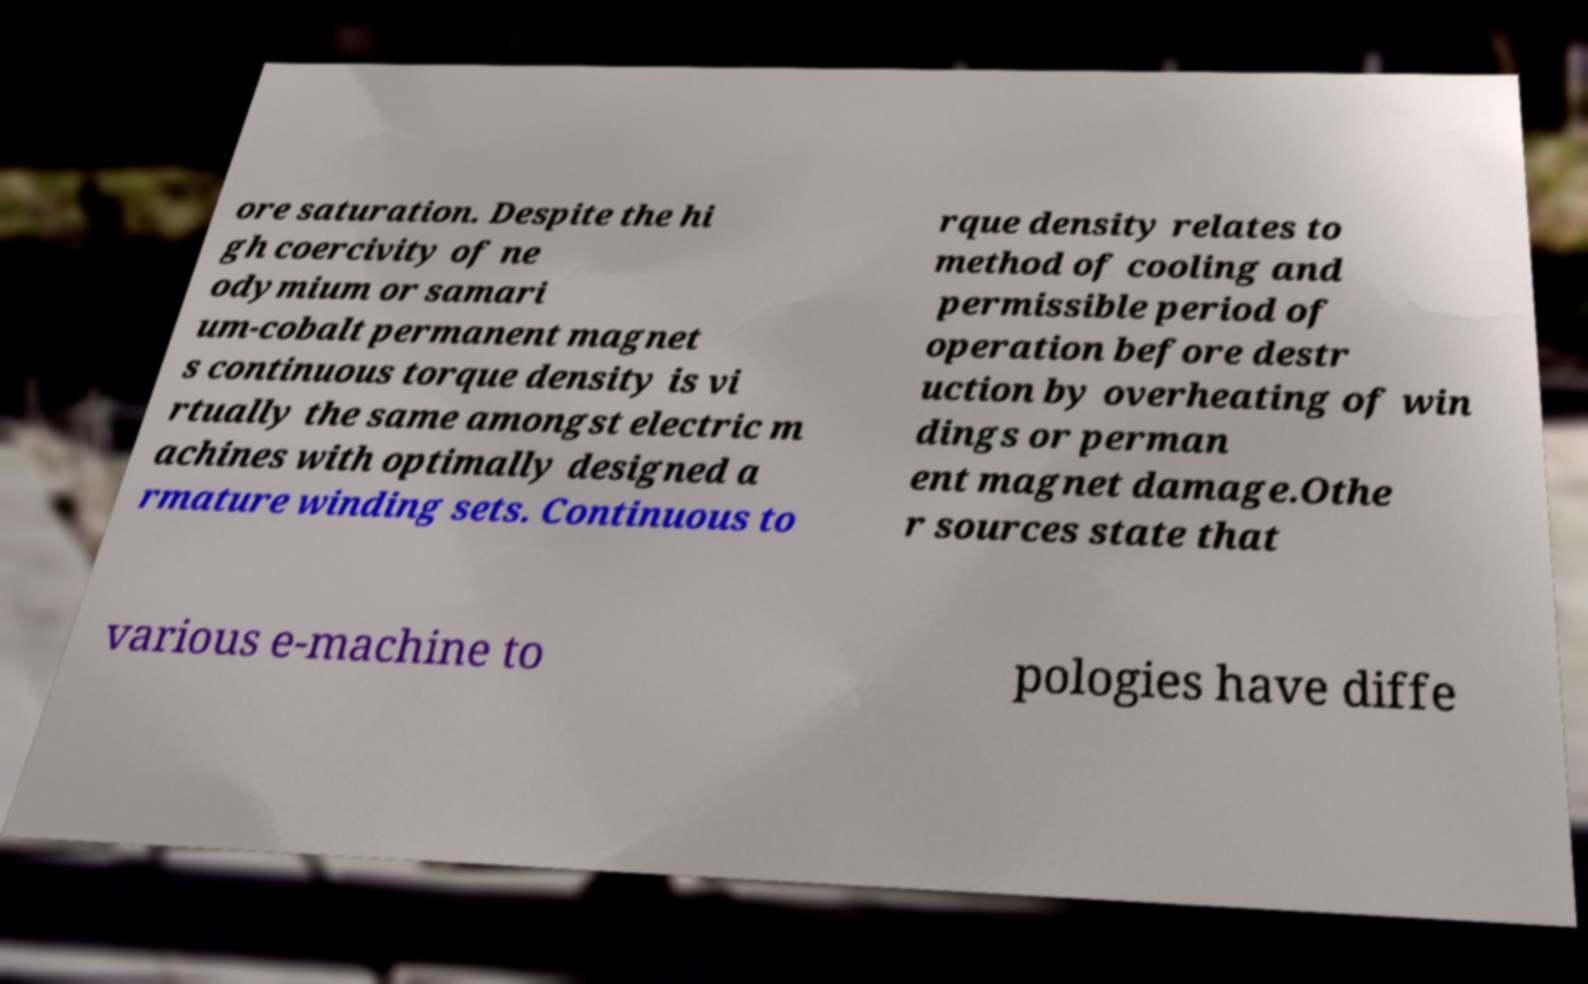Can you accurately transcribe the text from the provided image for me? ore saturation. Despite the hi gh coercivity of ne odymium or samari um-cobalt permanent magnet s continuous torque density is vi rtually the same amongst electric m achines with optimally designed a rmature winding sets. Continuous to rque density relates to method of cooling and permissible period of operation before destr uction by overheating of win dings or perman ent magnet damage.Othe r sources state that various e-machine to pologies have diffe 